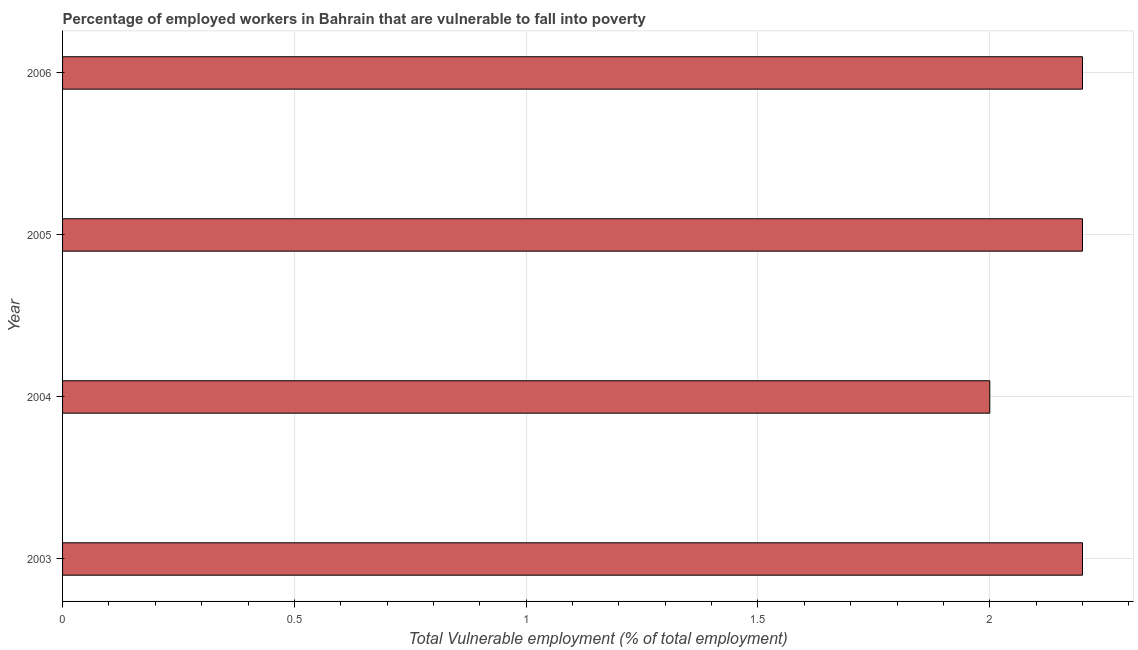What is the title of the graph?
Your answer should be compact. Percentage of employed workers in Bahrain that are vulnerable to fall into poverty. What is the label or title of the X-axis?
Ensure brevity in your answer.  Total Vulnerable employment (% of total employment). What is the total vulnerable employment in 2003?
Your response must be concise. 2.2. Across all years, what is the maximum total vulnerable employment?
Make the answer very short. 2.2. In which year was the total vulnerable employment maximum?
Provide a succinct answer. 2003. In which year was the total vulnerable employment minimum?
Provide a short and direct response. 2004. What is the sum of the total vulnerable employment?
Your answer should be compact. 8.6. What is the average total vulnerable employment per year?
Make the answer very short. 2.15. What is the median total vulnerable employment?
Your response must be concise. 2.2. Do a majority of the years between 2003 and 2006 (inclusive) have total vulnerable employment greater than 1.9 %?
Give a very brief answer. Yes. What is the ratio of the total vulnerable employment in 2003 to that in 2004?
Offer a very short reply. 1.1. Is the total vulnerable employment in 2004 less than that in 2006?
Ensure brevity in your answer.  Yes. Is the difference between the total vulnerable employment in 2003 and 2004 greater than the difference between any two years?
Keep it short and to the point. Yes. What is the difference between the highest and the second highest total vulnerable employment?
Give a very brief answer. 0. What is the difference between the highest and the lowest total vulnerable employment?
Your response must be concise. 0.2. How many bars are there?
Give a very brief answer. 4. Are all the bars in the graph horizontal?
Offer a terse response. Yes. How many years are there in the graph?
Keep it short and to the point. 4. Are the values on the major ticks of X-axis written in scientific E-notation?
Provide a succinct answer. No. What is the Total Vulnerable employment (% of total employment) in 2003?
Your response must be concise. 2.2. What is the Total Vulnerable employment (% of total employment) in 2004?
Your answer should be very brief. 2. What is the Total Vulnerable employment (% of total employment) in 2005?
Your response must be concise. 2.2. What is the Total Vulnerable employment (% of total employment) of 2006?
Ensure brevity in your answer.  2.2. What is the difference between the Total Vulnerable employment (% of total employment) in 2003 and 2006?
Provide a succinct answer. 0. What is the difference between the Total Vulnerable employment (% of total employment) in 2005 and 2006?
Give a very brief answer. 0. What is the ratio of the Total Vulnerable employment (% of total employment) in 2003 to that in 2004?
Your response must be concise. 1.1. What is the ratio of the Total Vulnerable employment (% of total employment) in 2004 to that in 2005?
Provide a short and direct response. 0.91. What is the ratio of the Total Vulnerable employment (% of total employment) in 2004 to that in 2006?
Offer a very short reply. 0.91. 